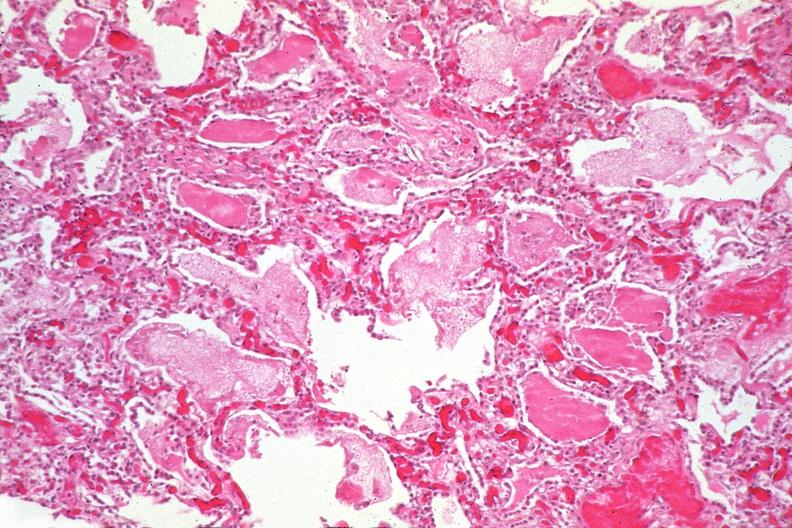where is this?
Answer the question using a single word or phrase. Lung 